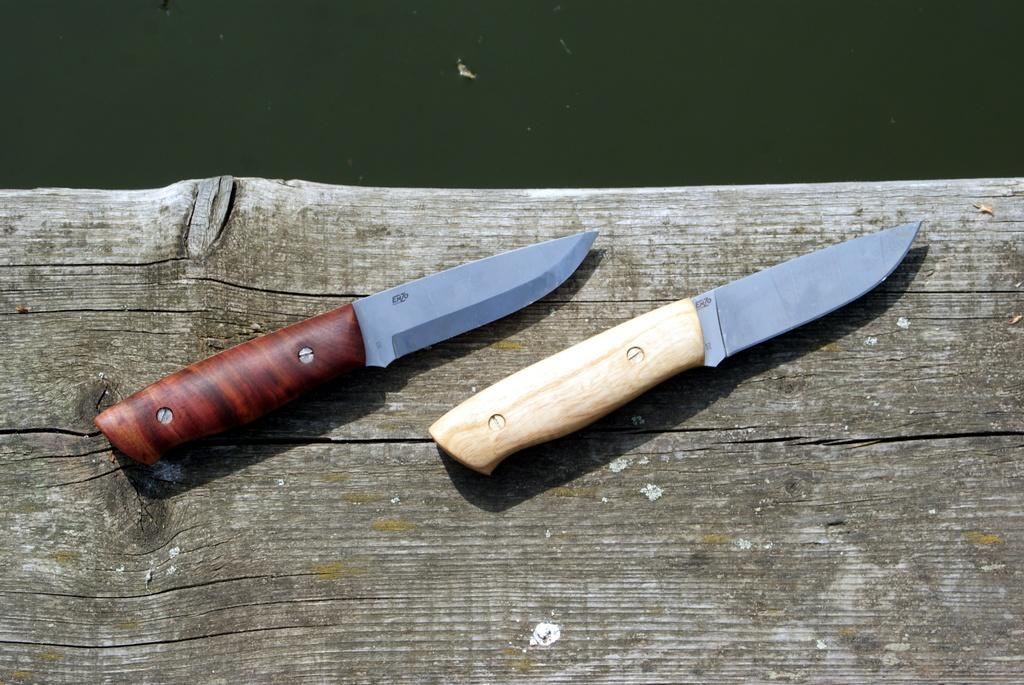How many knives are in the image? There are two knives in the image. What is the knives placed on? The knives are placed on a wooden object. What can be seen at the top of the image? There is water visible at the top of the image. What type of patch is being sewn onto the knives in the image? There is no patch or sewing activity present in the image; it only features two knives placed on a wooden object and water visible at the top. 